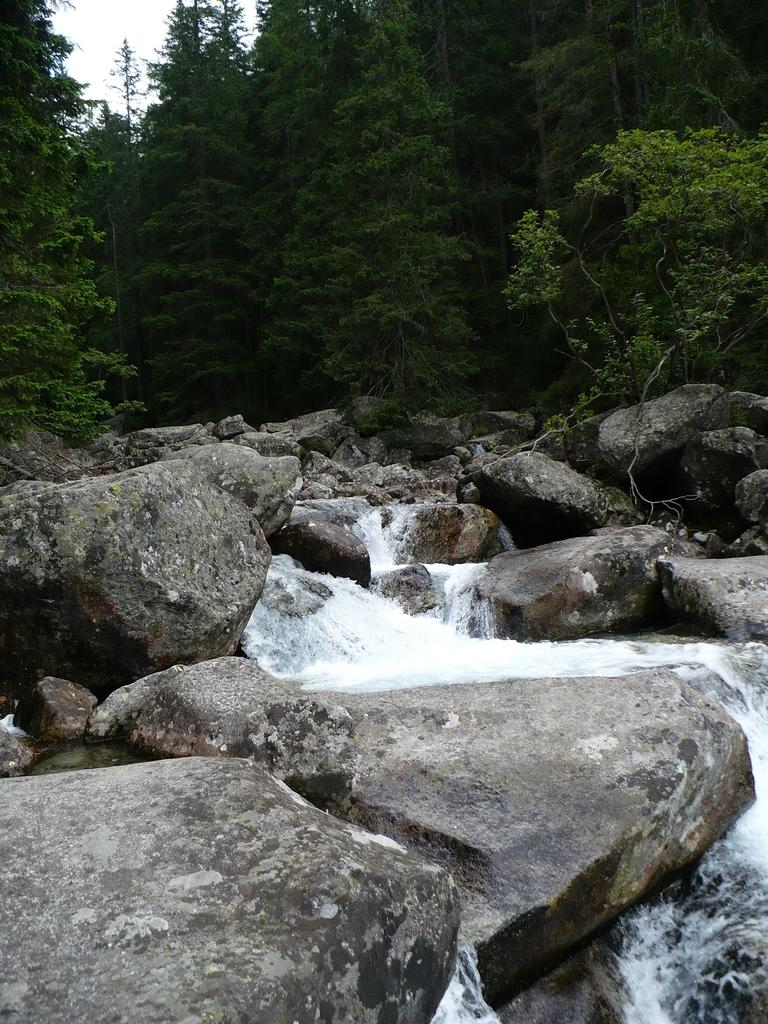What natural feature is the main subject of the image? There is a waterfall in the image. What other elements can be seen around the waterfall? Rocks and trees are visible in the image. What is visible in the background of the image? The sky is visible in the image. What type of pancake is being served at the waterfall in the image? There is no pancake present in the image; it features a waterfall, rocks, trees, and the sky. 